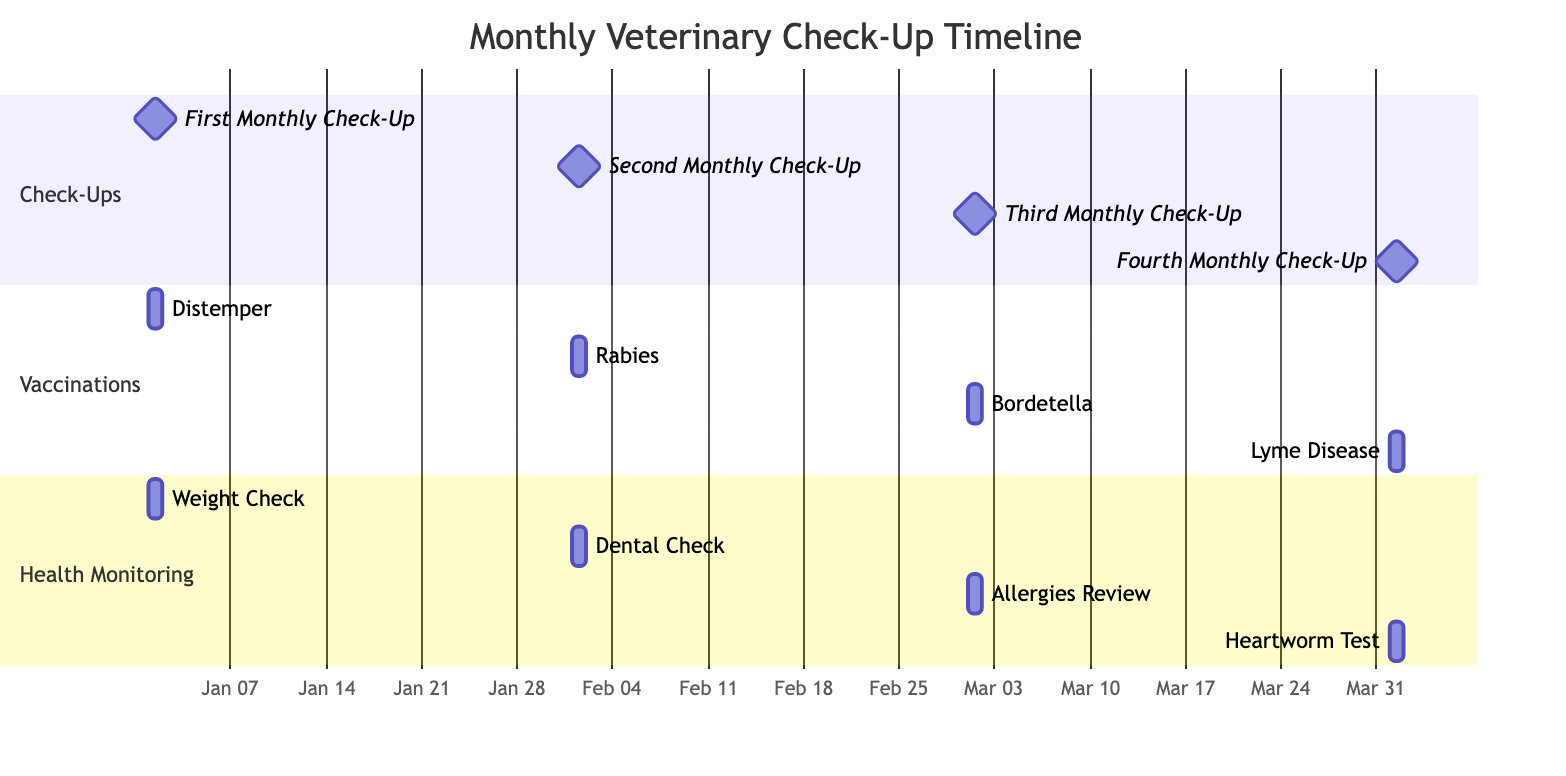What is the total number of check-ups scheduled in the timeline? The diagram lists four specific tasks labeled as "Check-Ups" which are the First, Second, Third, and Fourth Monthly Check-Ups. Counting these gives a total of four check-ups.
Answer: 4 When is the heartworm test scheduled? The health monitoring task labeled "Heartworm Test" is associated with the date of April 1, 2024, as depicted in the diagram.
Answer: April 1, 2024 Which vaccination follows the distemper vaccination? The distemper vaccination occurs on January 1, 2024. Following the sequence in the diagram, the next vaccination scheduled is the rabies vaccination on February 1, 2024.
Answer: Rabies How many health monitoring activities are listed? The diagram shows four tasks under "Health Monitoring" which are Weight Check, Dental Check, Allergies Review, and Heartworm Test. Counting these provides the total number of health monitoring activities.
Answer: 4 What month does the vaccination for Lyme Disease occur? Referring to the "Vaccinations" section in the diagram, the Lyme Disease vaccination is shown on April 1, 2024.
Answer: April What is the relationship between dental check and the second monthly check-up? The dental check is classified under health monitoring scheduled for February 1, 2024, which is the same date the second monthly check-up occurs. Therefore, they are both scheduled for the same day.
Answer: Same day Which task is scheduled on March 1, 2024? The diagram indicates three tasks scheduled on March 1, 2024, including the Third Monthly Check-Up, Bordetella vaccination, and Allergies Review. Thus, all those tasks correspond to that date.
Answer: Third Monthly Check-Up, Bordetella, Allergies Review In which section would you find the weight check? The weight check is categorized under "Health Monitoring." This section specifically includes tasks related to the ongoing health evaluation of the dog.
Answer: Health Monitoring How long do the tasks in the diagram individually last? Each task in the diagram is denoted with a duration of one day, as indicated in the format used for each task (1d).
Answer: 1 day 